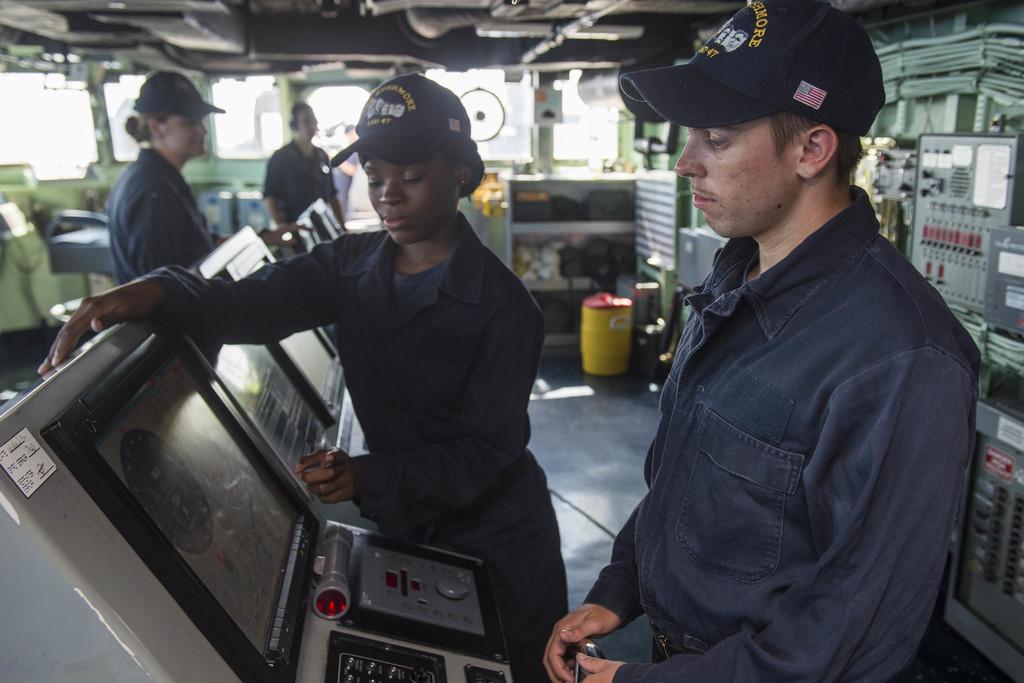In one or two sentences, can you explain what this image depicts? There is a woman in gray color dress, standing and operating a screen near a person who is standing on the floor. In the background, there are two persons, there is an yellow color tin on the floor, there are boards, roof, glass windows and other objects. 